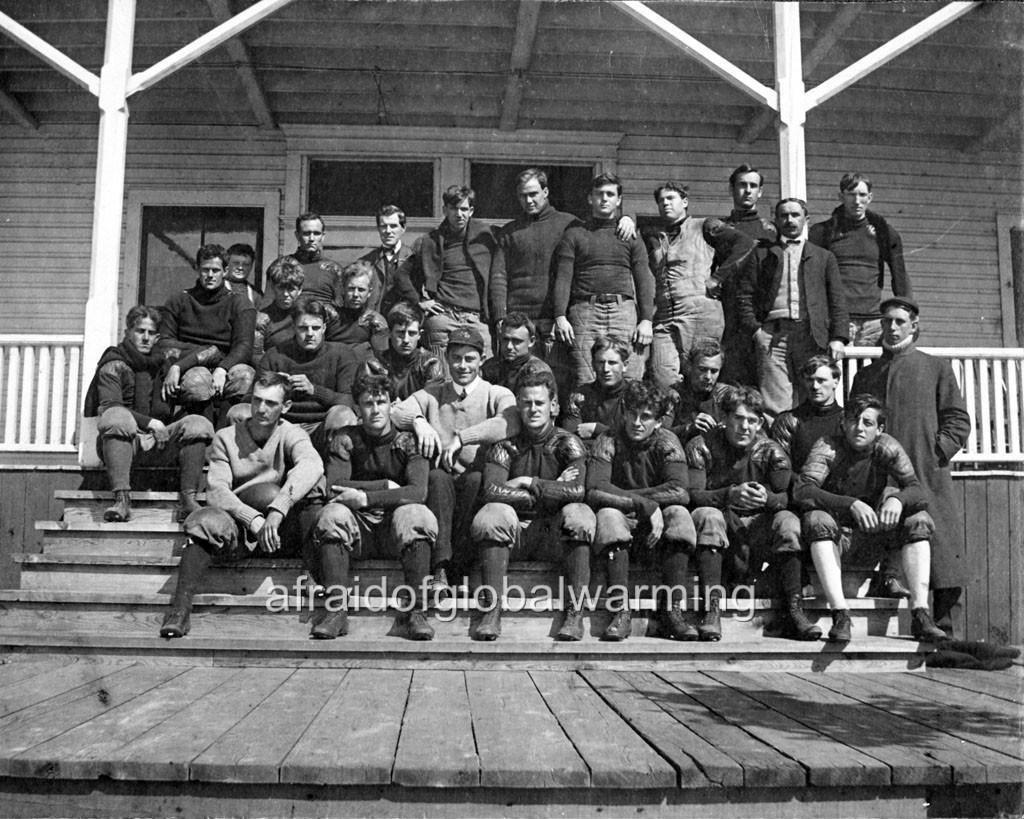What are the people in the image doing? There are persons sitting on the stairs and standing on the floor in the image. Can you describe the setting in the image? There is a house with a fence in the background of the image. What type of coach can be seen in the image? There is no coach present in the image. How many trains are visible in the image? There are no trains visible in the image. 